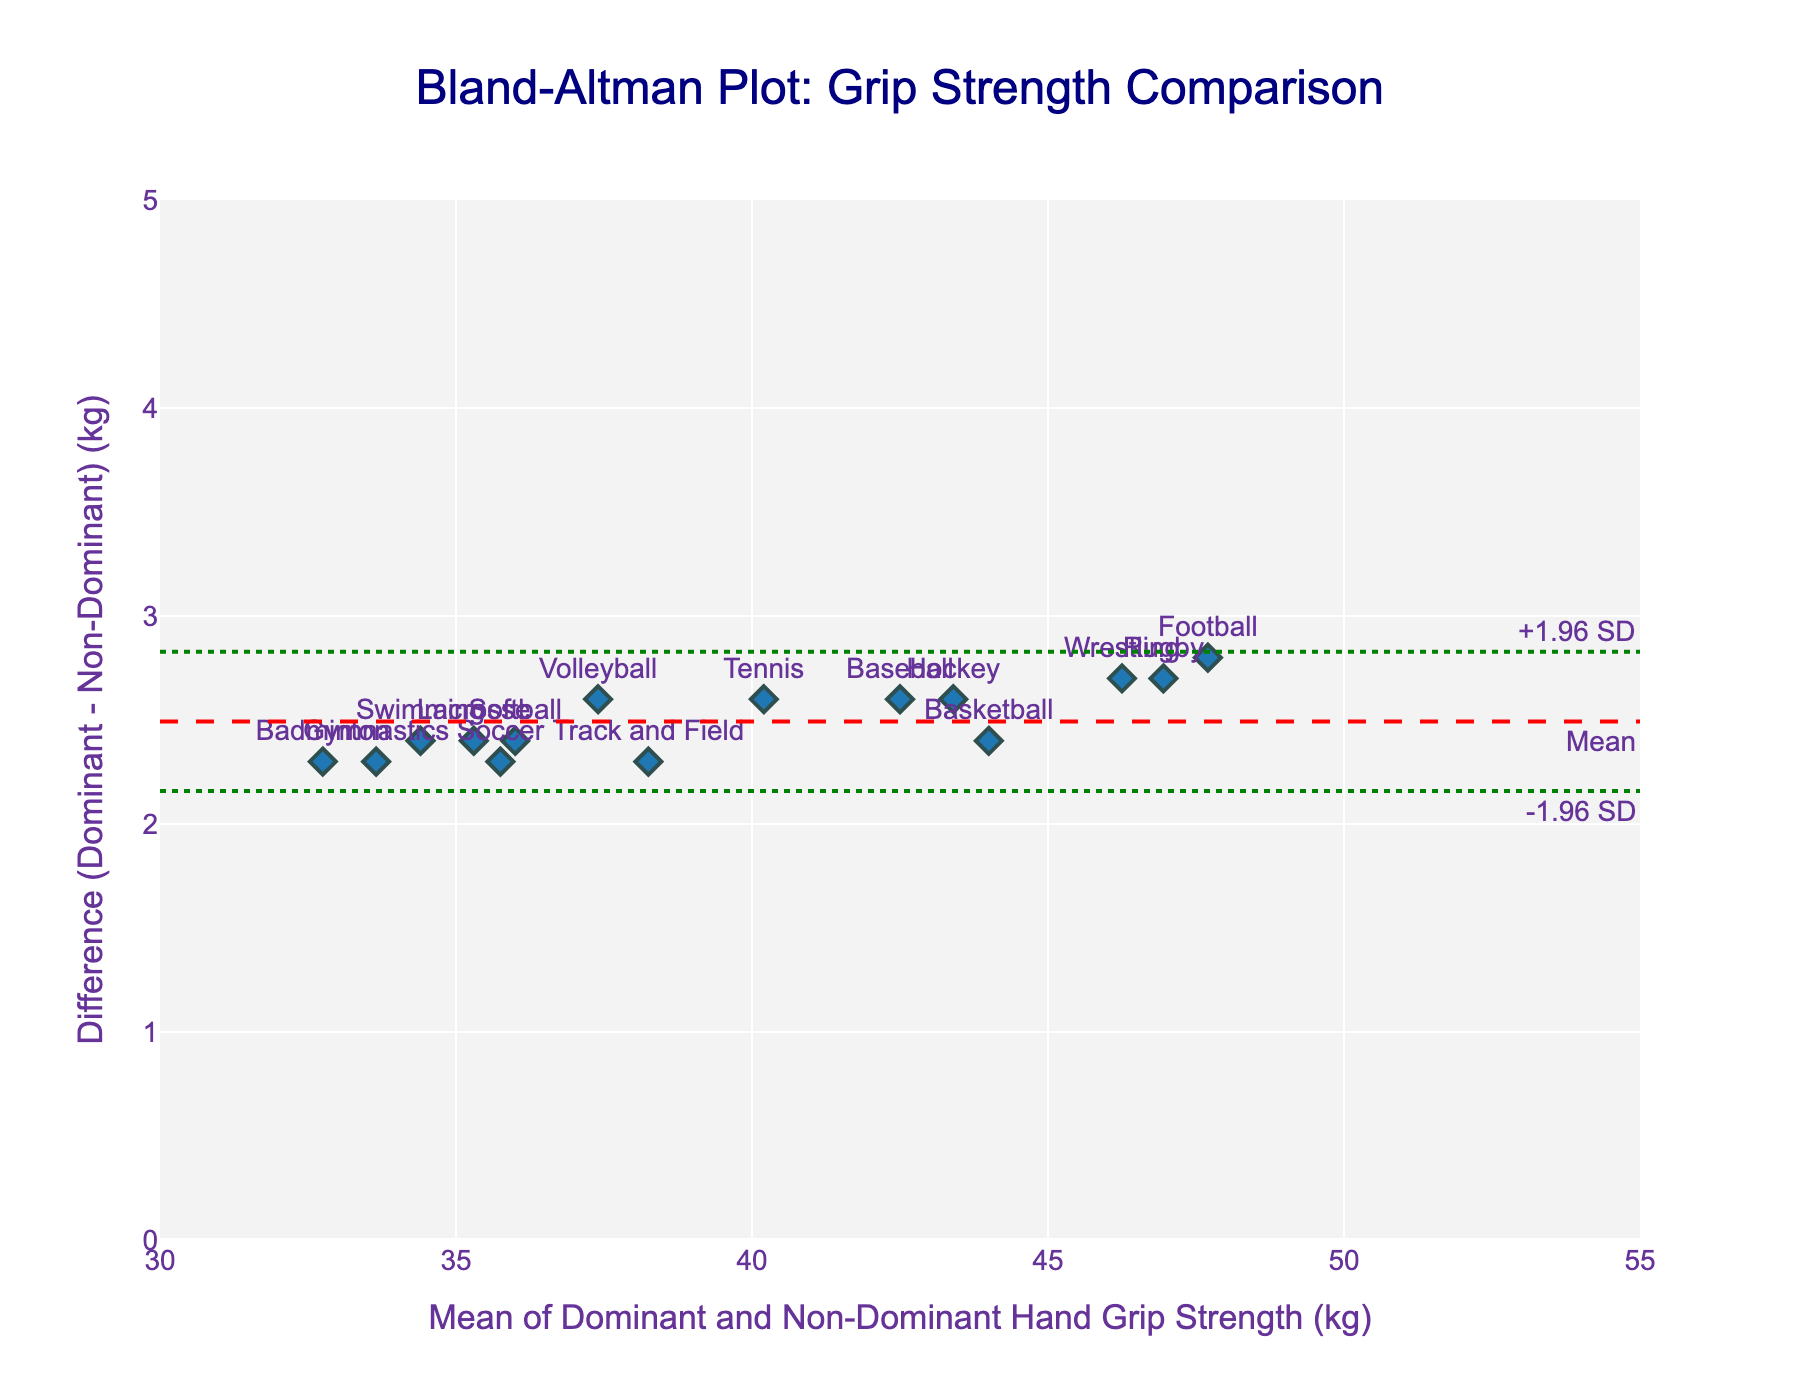What is the title of the plot? The title of the plot is generally placed at the top, and in this case, it reads: "Bland-Altman Plot: Grip Strength Comparison."
Answer: Bland-Altman Plot: Grip Strength Comparison What are the ranges of the x-axis and y-axis? The figure displays the range of the x-axis from 30 to 55 and the y-axis from 0 to 5. This can be seen from the axis labels and tick marks.
Answer: x-axis: 30 to 55, y-axis: 0 to 5 How many data points are plotted on the figure? The number of data points can be counted by looking at the individual markers in the scatter plot. By counting the markers, it can be seen that there are 15 data points.
Answer: 15 Which sport has the highest mean grip strength between dominant and non-dominant hands? Look for the marker representing the highest x-coordinate (mean of grip strengths). "Football" (Jake Wilson) is labeled at the approximate mean value of 47.7, which is the highest.
Answer: Football (Jake Wilson) What is the mean difference in grip strength between dominant and non-dominant hands? The mean difference is indicated by the dashed red horizontal line and is explicitly annotated in the figure.
Answer: Mean difference What are the limits of agreement in the plot? The limits of agreement are the dashed green lines, generally positioned at -1.96 SD and +1.96 SD. These are annotated in the figure as well.
Answer: -1.96 SD to +1.96 SD Which sport has the smallest difference in grip strength between dominant and non-dominant hands? Look for the marker closest to the y=0 line. "Gymnastics" (Sophia Lee) has a small difference around this value.
Answer: Gymnastics (Sophia Lee) What is the average of the dominant and non-dominant hand grip strength for Volleyball (Emily Johnson)? The mean is annotated around the x-value close to Emily Johnson’s dot. It’s about (38.7 + 36.1) / 2 = 37.4.
Answer: ~37.4 Are there any differences that fall outside the limits of agreement? Check if any markers fall outside the green dashed lines representing limits of agreement. All markers fall inside these lines.
Answer: No Which sports have their measurements clustered closely around the mean difference? Identify sports located near the red dashed line indicating the mean difference. "Swimming" (Olivia Williams) and "Soccer" (Sarah Rodriguez) appear close to this line.
Answer: Swimming (Olivia Williams) and Soccer (Sarah Rodriguez) 